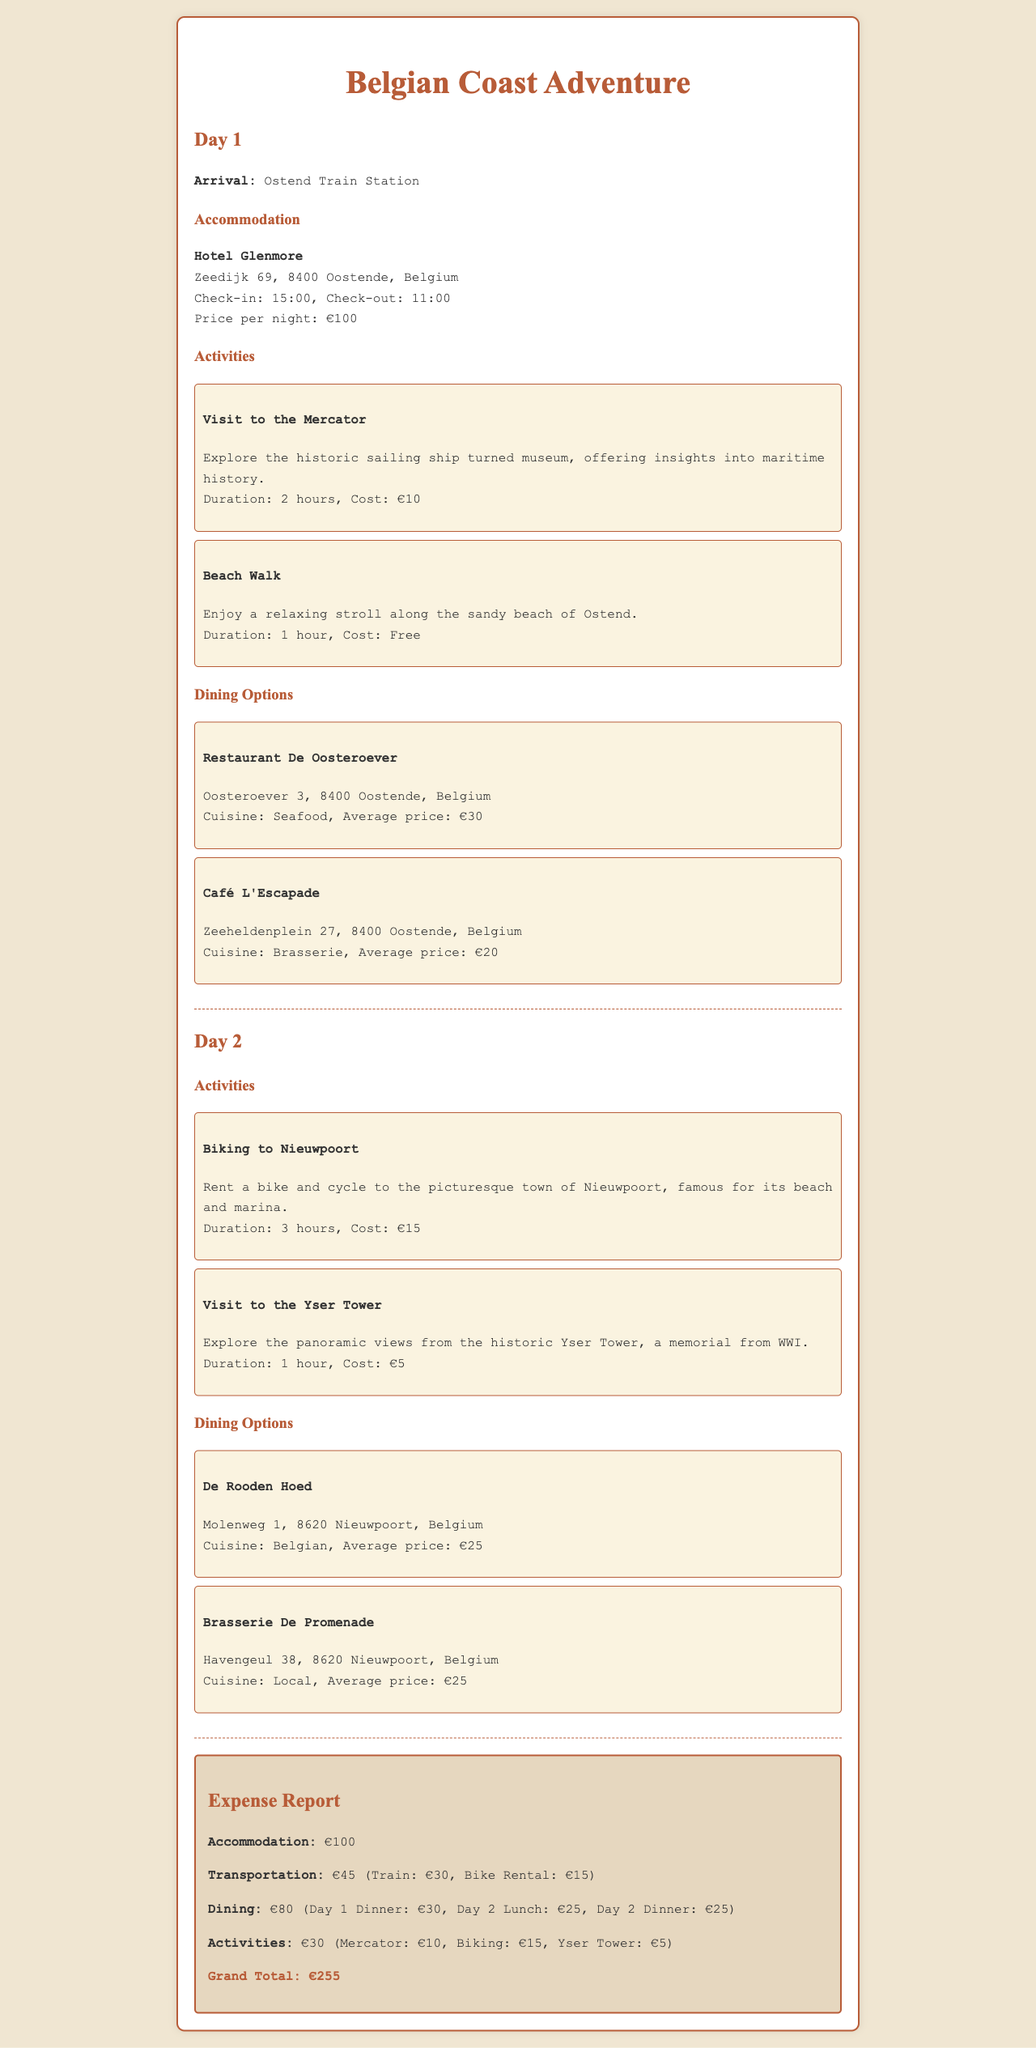What is the name of the hotel? The hotel's name is mentioned in the accommodation section of the report.
Answer: Hotel Glenmore What is the average price for dining at Restaurant De Oosteroever? The average price for dining at Restaurant De Oosteroever is listed in the dining options section.
Answer: €30 What activity costs €10? The cost of €10 is provided for specific activities in the activities section.
Answer: Visit to the Mercator What is the total expense for accommodation? The total expense for accommodation is directly stated in the expense report.
Answer: €100 How many hours is the biking activity? The duration of the biking activity is stated in the activities section of Day 2.
Answer: 3 hours What is the grand total expense for the trip? The grand total expense is the sum of all categories in the expense report.
Answer: €255 Where is Café L'Escapade located? The location of Café L'Escapade is given in the dining options section.
Answer: Zeeheldenplein 27, 8400 Oostende, Belgium What type of cuisine does De Rooden Hoed serve? The type of cuisine offered at De Rooden Hoed is listed in the dining options section.
Answer: Belgian Which activity is free of charge? The information about free activities is outlined in the activities section.
Answer: Beach Walk 